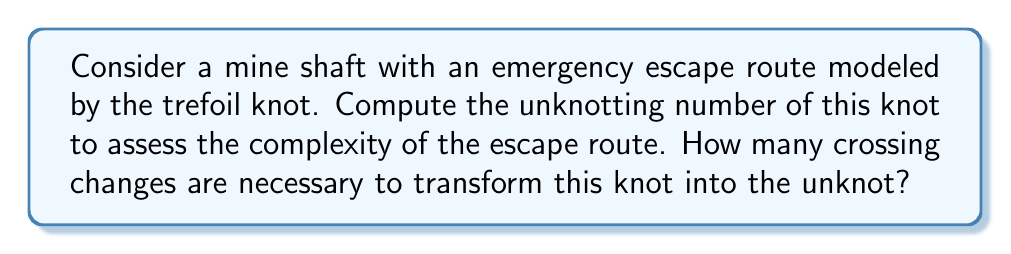Solve this math problem. To compute the unknotting number of the trefoil knot, we'll follow these steps:

1. Recall that the unknotting number is the minimum number of crossing changes needed to transform a knot into the unknot.

2. The trefoil knot is one of the simplest non-trivial knots, represented by the following diagram:

[asy]
import geometry;

pair A = (0,1), B = (-0.866,-0.5), C = (0.866,-0.5);
path p = A--B--C--cycle;
draw(p, blue+1);
draw(A--C, blue+1);
dot(A,blue); dot(B,blue); dot(C,blue);
[/asy]

3. Observe that the trefoil knot has three crossings in its minimal diagram.

4. To unknot the trefoil, we need to change at least one of these crossings. Let's attempt to change one crossing:

[asy]
import geometry;

pair A = (0,1), B = (-0.866,-0.5), C = (0.866,-0.5);
path p = A--B--C--cycle;
draw(p, blue+1);
draw(C--A, blue+1);
dot(A,blue); dot(B,blue); dot(C,blue);
[/asy]

5. After changing one crossing, we obtain the unknot:

[asy]
import geometry;

pair A = (0,1), B = (-0.866,-0.5), C = (0.866,-0.5);
path p = A--B--C--cycle;
draw(p, blue+1);
dot(A,blue); dot(B,blue); dot(C,blue);
[/asy]

6. Therefore, the unknotting number of the trefoil knot is 1.

This result indicates that the emergency escape route modeled by the trefoil knot has a relatively low complexity, as only one "crossing change" (which could represent a single critical decision point or obstacle) needs to be navigated to simplify the route.
Answer: 1 